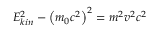<formula> <loc_0><loc_0><loc_500><loc_500>E _ { k i n } ^ { 2 } - \left ( m _ { 0 } c ^ { 2 } \right ) ^ { 2 } = m ^ { 2 } v ^ { 2 } c ^ { 2 }</formula> 